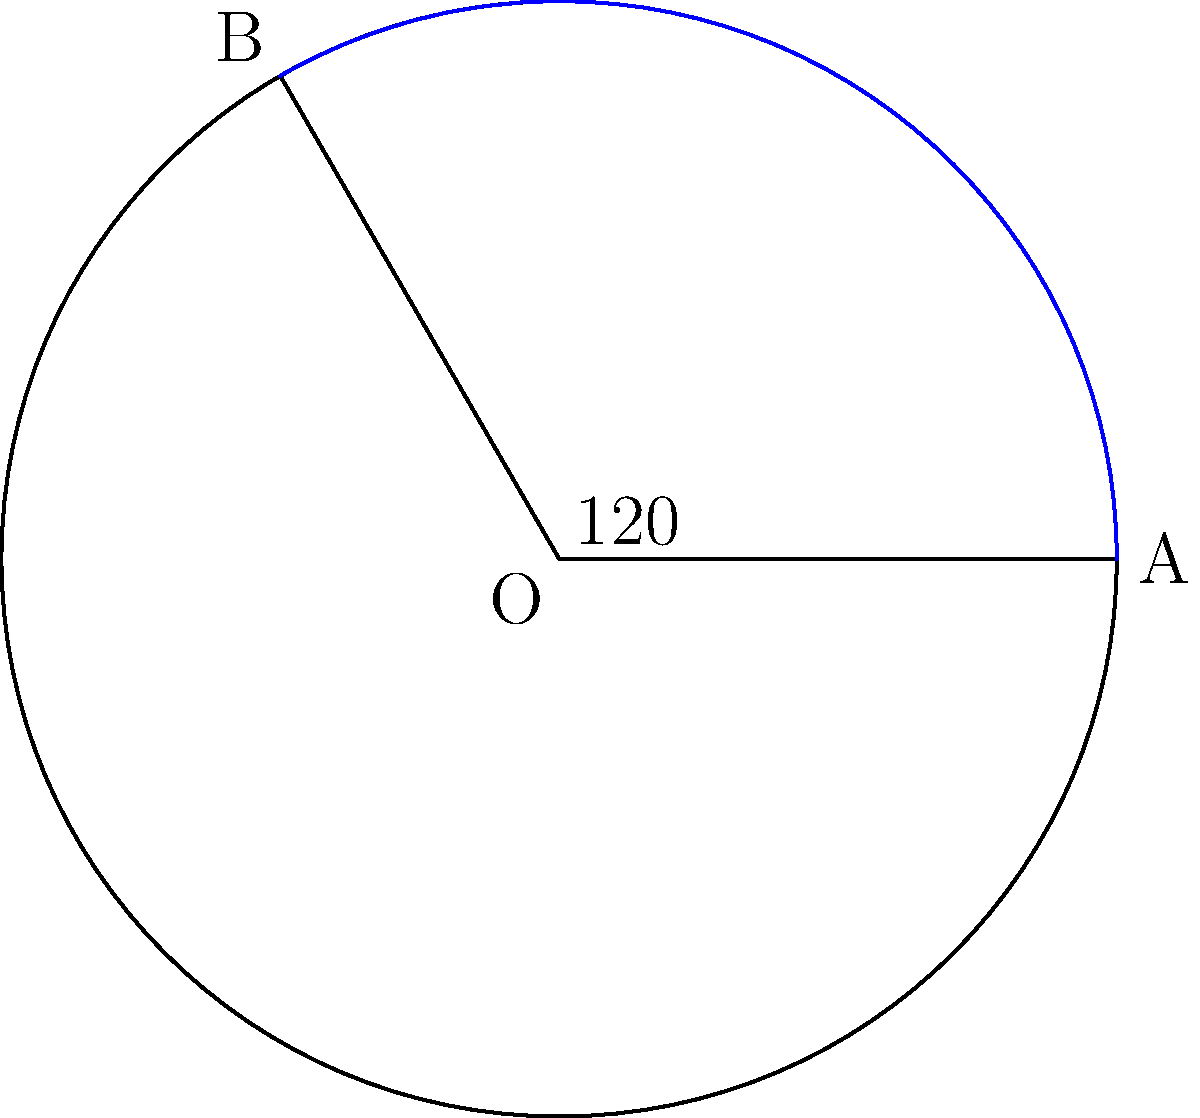In your digital marketing campaign for your small business in Jalandhar, you're designing a circular logo. The logo includes a sector with a central angle of $120°$ and a radius of 18 cm. What is the area of this sector in square centimeters? Round your answer to the nearest whole number. To find the area of a sector, we need to follow these steps:

1) The formula for the area of a sector is:

   $$A = \frac{\theta}{360°} \cdot \pi r^2$$

   Where $A$ is the area, $\theta$ is the central angle in degrees, and $r$ is the radius.

2) We're given:
   $\theta = 120°$
   $r = 18$ cm

3) Let's substitute these values into our formula:

   $$A = \frac{120°}{360°} \cdot \pi (18 \text{ cm})^2$$

4) Simplify:
   $$A = \frac{1}{3} \cdot \pi \cdot 324 \text{ cm}^2$$

5) Calculate:
   $$A = 108\pi \text{ cm}^2$$

6) Use $\pi \approx 3.14159$:
   $$A \approx 108 \cdot 3.14159 \text{ cm}^2 \approx 339.29 \text{ cm}^2$$

7) Rounding to the nearest whole number:
   $$A \approx 339 \text{ cm}^2$$
Answer: 339 cm² 